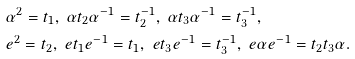<formula> <loc_0><loc_0><loc_500><loc_500>& \alpha ^ { 2 } = t _ { 1 } , \ \alpha t _ { 2 } \alpha ^ { - 1 } = t _ { 2 } ^ { - 1 } , \ \alpha t _ { 3 } \alpha ^ { - 1 } = t _ { 3 } ^ { - 1 } , \\ & e ^ { 2 } = t _ { 2 } , \ e t _ { 1 } e ^ { - 1 } = t _ { 1 } , \ e t _ { 3 } e ^ { - 1 } = t _ { 3 } ^ { - 1 } , \ e \alpha e ^ { - 1 } = t _ { 2 } t _ { 3 } \alpha .</formula> 